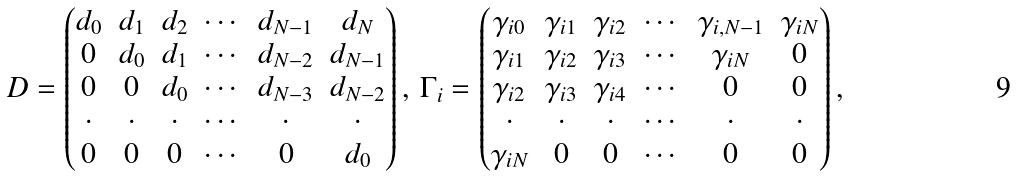<formula> <loc_0><loc_0><loc_500><loc_500>D = \begin{pmatrix} d _ { 0 } & d _ { 1 } & d _ { 2 } & \cdots & d _ { N - 1 } & d _ { N } \\ 0 & d _ { 0 } & d _ { 1 } & \cdots & d _ { N - 2 } & d _ { N - 1 } \\ 0 & 0 & d _ { 0 } & \cdots & d _ { N - 3 } & d _ { N - 2 } \\ \cdot & \cdot & \cdot & \cdots & \cdot & \cdot \\ 0 & 0 & 0 & \cdots & 0 & d _ { 0 } \end{pmatrix} , \, \Gamma _ { i } = \begin{pmatrix} \gamma _ { i 0 } & \gamma _ { i 1 } & \gamma _ { i 2 } & \cdots & \gamma _ { i , N - 1 } & \gamma _ { i N } \\ \gamma _ { i 1 } & \gamma _ { i 2 } & \gamma _ { i 3 } & \cdots & \gamma _ { i N } & 0 \\ \gamma _ { i 2 } & \gamma _ { i 3 } & \gamma _ { i 4 } & \cdots & 0 & 0 \\ \cdot & \cdot & \cdot & \cdots & \cdot & \cdot \\ \gamma _ { i N } & 0 & 0 & \cdots & 0 & 0 \end{pmatrix} ,</formula> 